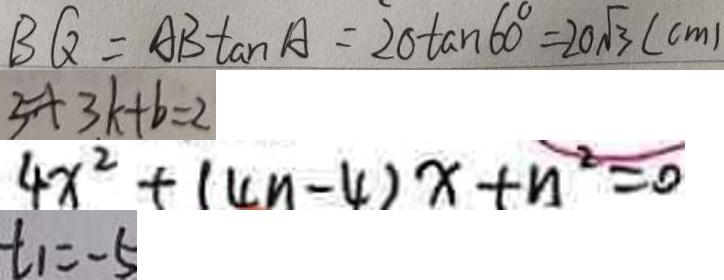Convert formula to latex. <formula><loc_0><loc_0><loc_500><loc_500>B Q = A B \tan A = 2 0 \tan 6 0 ^ { \circ } = 2 0 \sqrt { 3 } ( c m ) 
 5 + 3 k + b = 2 
 4 x ^ { 2 } + ( 4 n - 4 ) x + n ^ { 2 } = 0 
 t _ { 1 } = - 5</formula> 